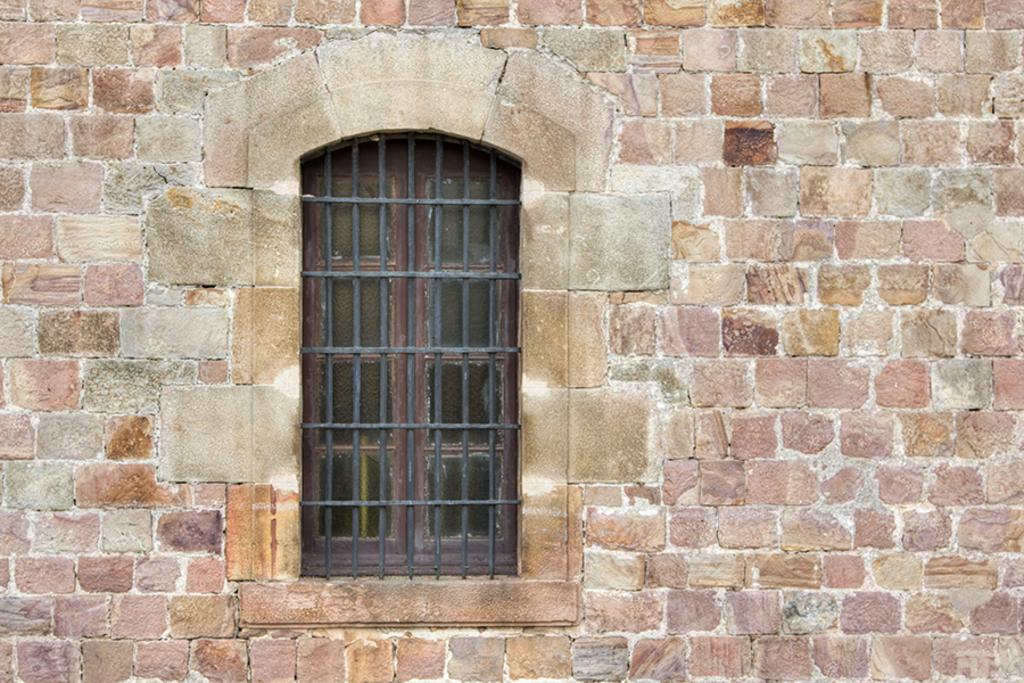What type of wall is visible in the image? There is a brick wall in the image. Are there any openings in the brick wall? Yes, there is a window in the brick wall. What type of security feature is present on the window? Iron grills are present on the window. How many quills can be seen sticking out of the brick wall in the image? There are no quills present in the image; it features a brick wall with a window and iron grills. 